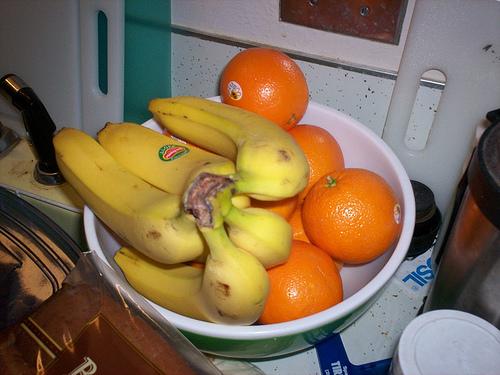What is the container made of?
Answer briefly. Ceramic. How many oranges have been peeled?
Write a very short answer. 0. Does the fruit look like a face?
Be succinct. No. What color is the bowl?
Give a very brief answer. Green. How can you tell the fruit were store bought?
Concise answer only. Stickers. What kind of fruit is shown?
Short answer required. Bananas and oranges. What brand are the bananas?
Keep it brief. Del monte. Is this photo taken indoors?
Give a very brief answer. Yes. 